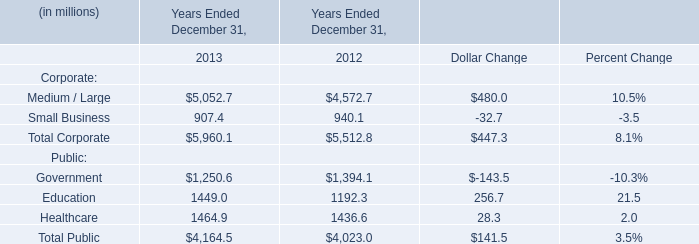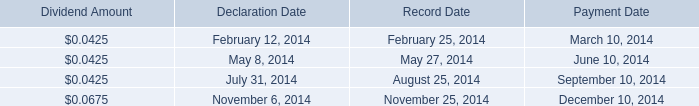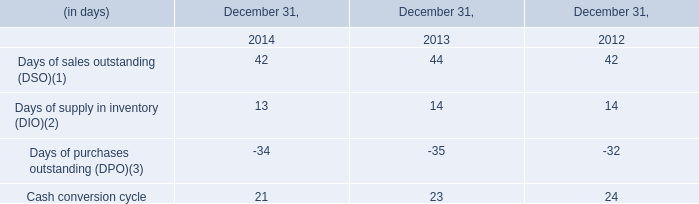How much of public is there in total in 2013 without education and healthcare? (in million) 
Answer: 1250.6. 